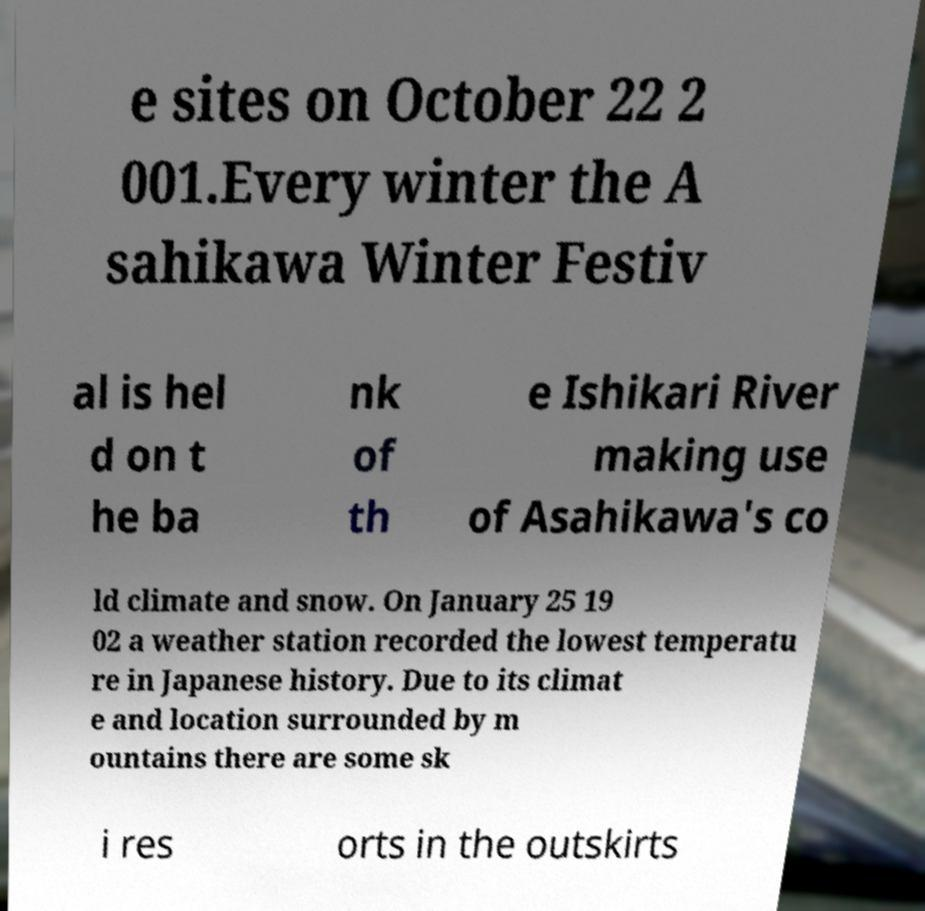What messages or text are displayed in this image? I need them in a readable, typed format. e sites on October 22 2 001.Every winter the A sahikawa Winter Festiv al is hel d on t he ba nk of th e Ishikari River making use of Asahikawa's co ld climate and snow. On January 25 19 02 a weather station recorded the lowest temperatu re in Japanese history. Due to its climat e and location surrounded by m ountains there are some sk i res orts in the outskirts 